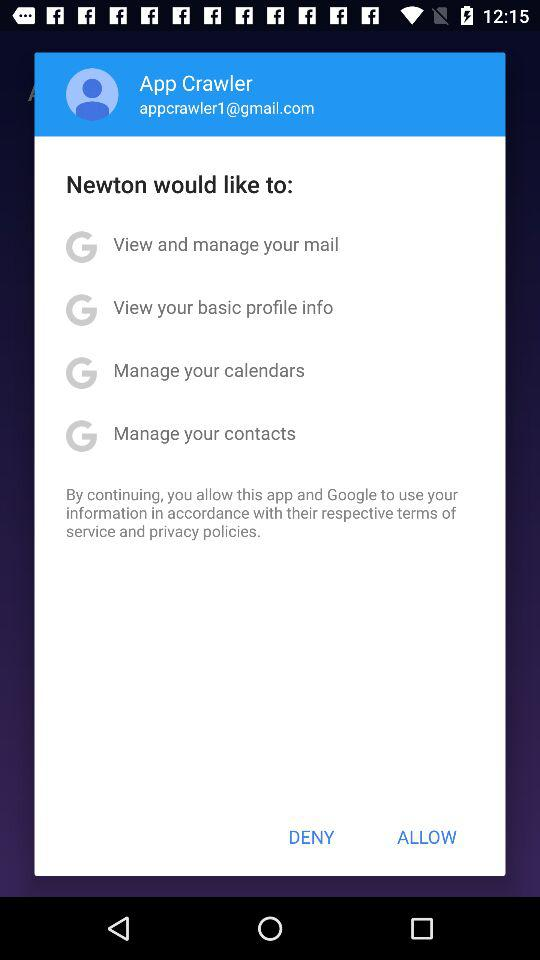What is the email address of the user? The email address of the user is appcrawler1@gmail.com. 